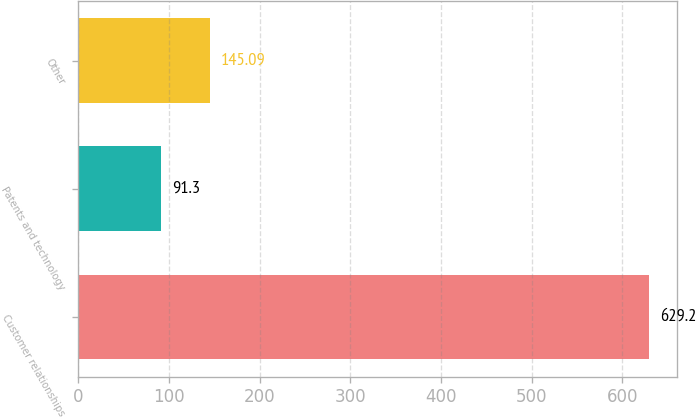Convert chart. <chart><loc_0><loc_0><loc_500><loc_500><bar_chart><fcel>Customer relationships<fcel>Patents and technology<fcel>Other<nl><fcel>629.2<fcel>91.3<fcel>145.09<nl></chart> 